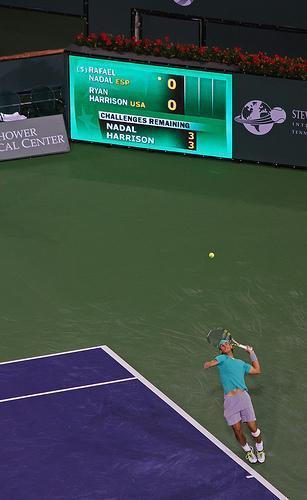How many players are shown?
Give a very brief answer. 1. 